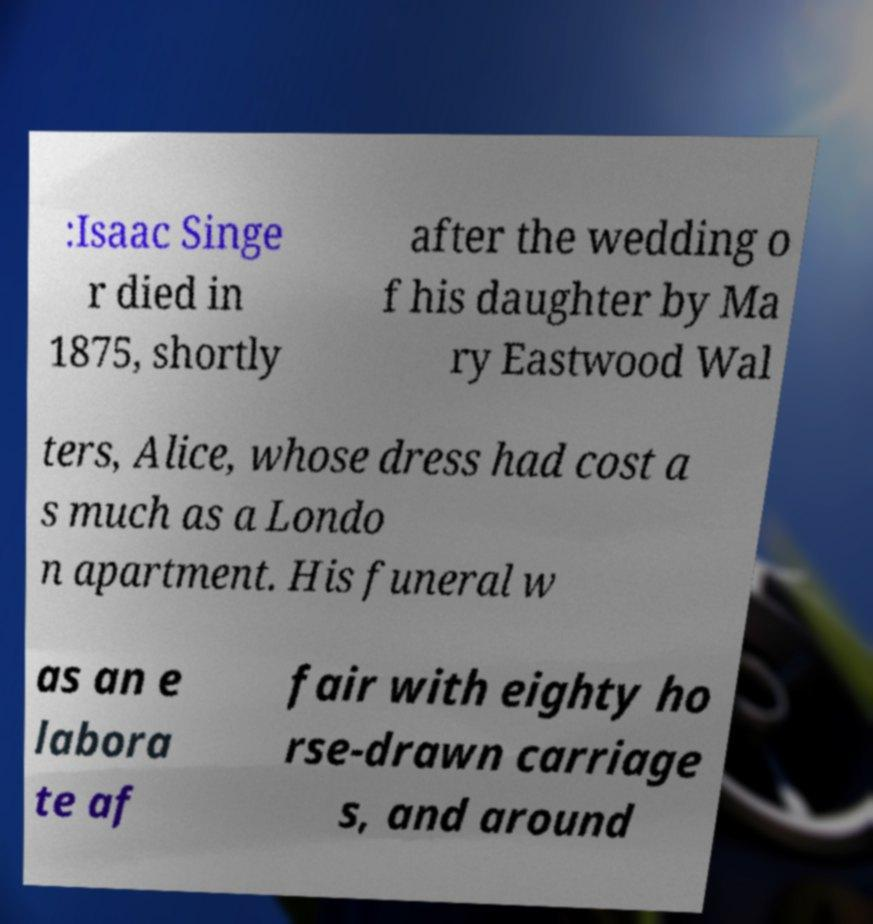Could you extract and type out the text from this image? :Isaac Singe r died in 1875, shortly after the wedding o f his daughter by Ma ry Eastwood Wal ters, Alice, whose dress had cost a s much as a Londo n apartment. His funeral w as an e labora te af fair with eighty ho rse-drawn carriage s, and around 